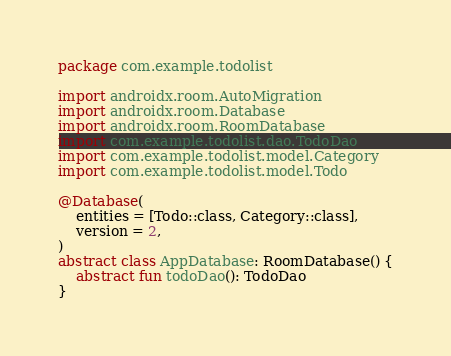Convert code to text. <code><loc_0><loc_0><loc_500><loc_500><_Kotlin_>package com.example.todolist

import androidx.room.AutoMigration
import androidx.room.Database
import androidx.room.RoomDatabase
import com.example.todolist.dao.TodoDao
import com.example.todolist.model.Category
import com.example.todolist.model.Todo

@Database(
    entities = [Todo::class, Category::class],
    version = 2,
)
abstract class AppDatabase: RoomDatabase() {
    abstract fun todoDao(): TodoDao
}</code> 